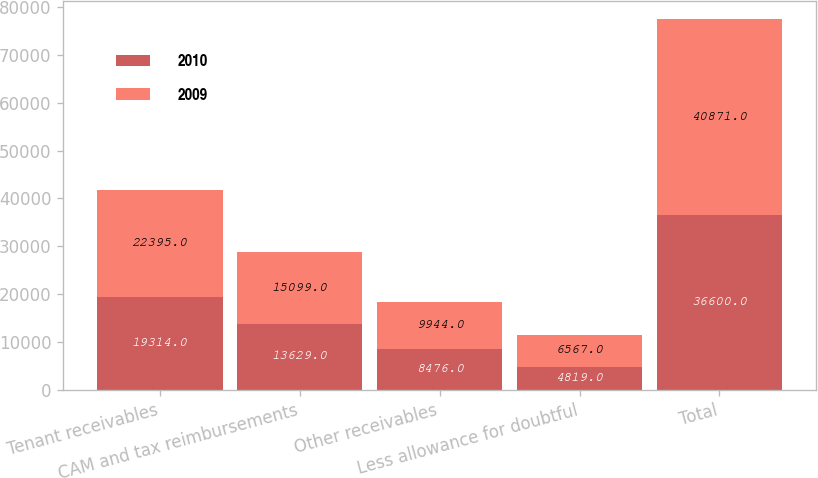Convert chart to OTSL. <chart><loc_0><loc_0><loc_500><loc_500><stacked_bar_chart><ecel><fcel>Tenant receivables<fcel>CAM and tax reimbursements<fcel>Other receivables<fcel>Less allowance for doubtful<fcel>Total<nl><fcel>2010<fcel>19314<fcel>13629<fcel>8476<fcel>4819<fcel>36600<nl><fcel>2009<fcel>22395<fcel>15099<fcel>9944<fcel>6567<fcel>40871<nl></chart> 